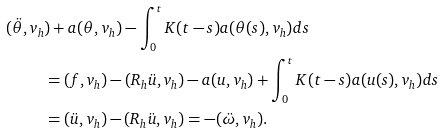Convert formula to latex. <formula><loc_0><loc_0><loc_500><loc_500>( \ddot { \theta } , v _ { h } & ) + a ( \theta , v _ { h } ) - \int _ { 0 } ^ { t } K ( t - s ) a ( \theta ( s ) , v _ { h } ) d s \\ & = ( f , v _ { h } ) - ( R _ { h } \ddot { u } , v _ { h } ) - a ( u , v _ { h } ) + \int _ { 0 } ^ { t } K ( t - s ) a ( u ( s ) , v _ { h } ) d s \\ & = ( \ddot { u } , v _ { h } ) - ( R _ { h } \ddot { u } , v _ { h } ) = - ( \ddot { \omega } , v _ { h } ) .</formula> 